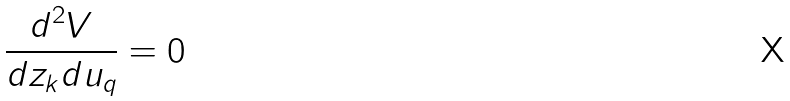Convert formula to latex. <formula><loc_0><loc_0><loc_500><loc_500>\frac { d ^ { 2 } V } { d z _ { k } d u _ { q } } = 0</formula> 